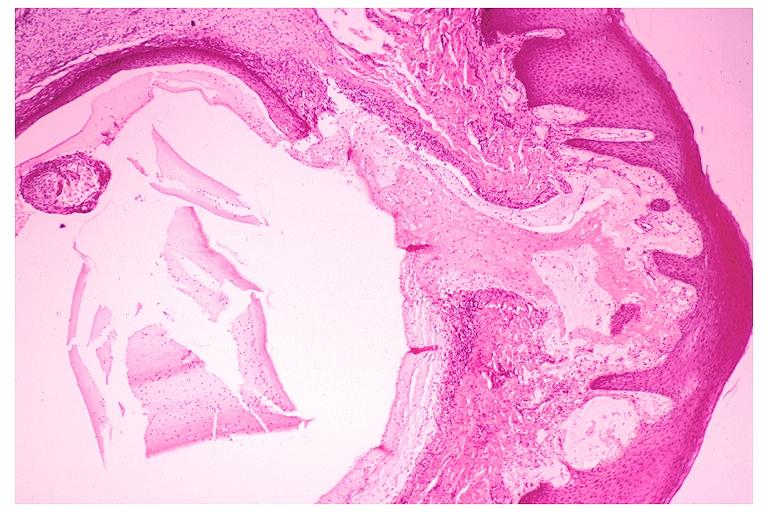does malignant lymphoma large cell type show mucocele?
Answer the question using a single word or phrase. No 